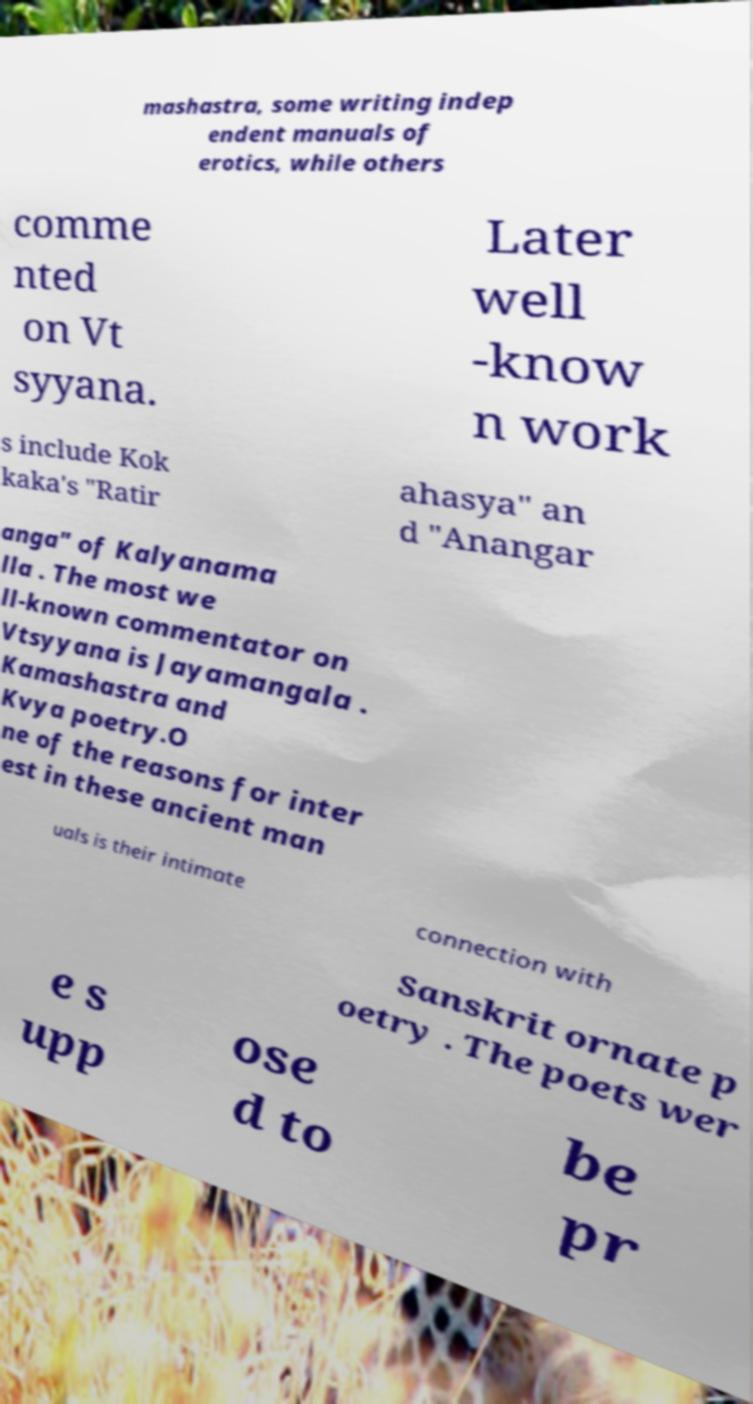Could you extract and type out the text from this image? mashastra, some writing indep endent manuals of erotics, while others comme nted on Vt syyana. Later well -know n work s include Kok kaka's "Ratir ahasya" an d "Anangar anga" of Kalyanama lla . The most we ll-known commentator on Vtsyyana is Jayamangala . Kamashastra and Kvya poetry.O ne of the reasons for inter est in these ancient man uals is their intimate connection with Sanskrit ornate p oetry . The poets wer e s upp ose d to be pr 